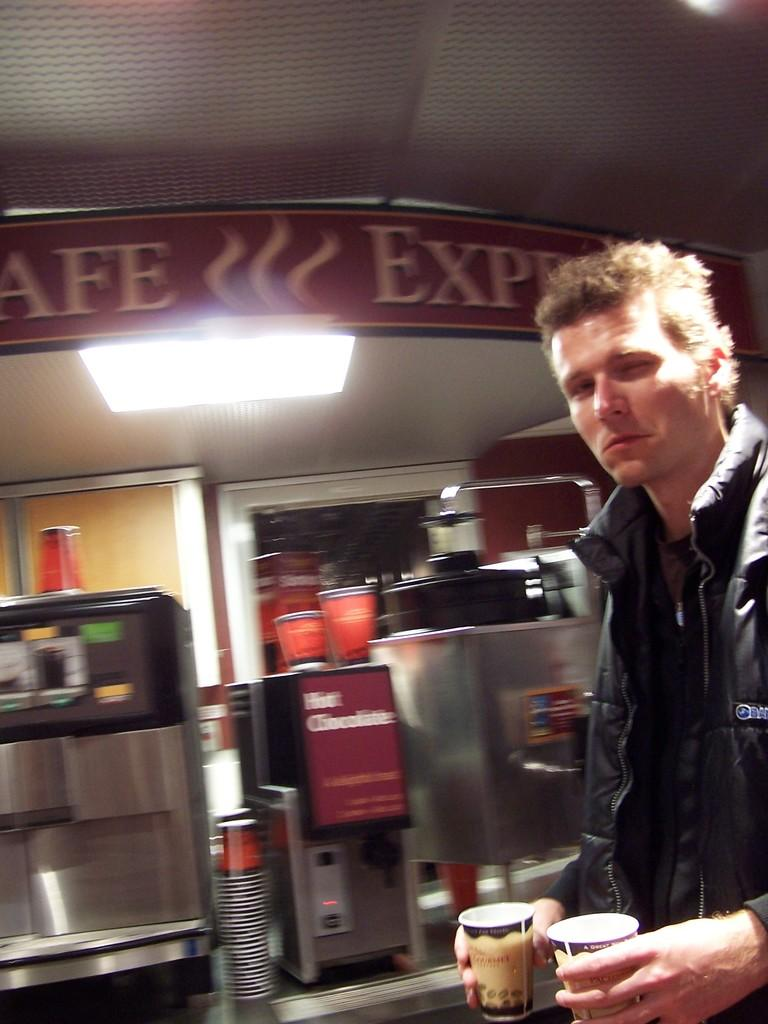<image>
Provide a brief description of the given image. A man stands in front of a hot chocolate machine. 